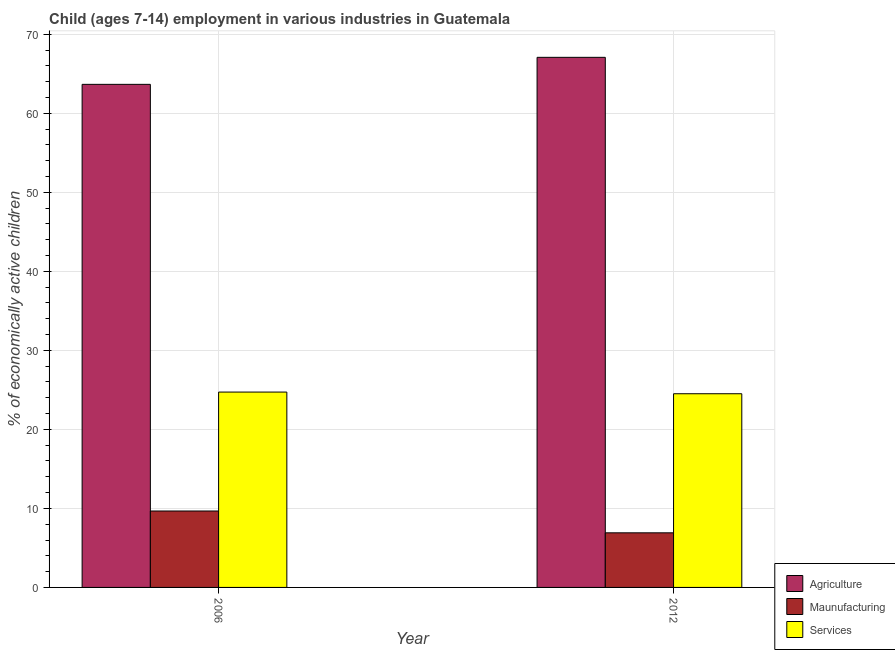How many bars are there on the 2nd tick from the right?
Your answer should be compact. 3. In how many cases, is the number of bars for a given year not equal to the number of legend labels?
Make the answer very short. 0. What is the percentage of economically active children in services in 2006?
Keep it short and to the point. 24.72. Across all years, what is the maximum percentage of economically active children in agriculture?
Offer a very short reply. 67.08. Across all years, what is the minimum percentage of economically active children in services?
Ensure brevity in your answer.  24.51. In which year was the percentage of economically active children in manufacturing maximum?
Ensure brevity in your answer.  2006. What is the total percentage of economically active children in agriculture in the graph?
Keep it short and to the point. 130.74. What is the difference between the percentage of economically active children in manufacturing in 2006 and that in 2012?
Your response must be concise. 2.76. What is the difference between the percentage of economically active children in manufacturing in 2006 and the percentage of economically active children in agriculture in 2012?
Provide a short and direct response. 2.76. What is the average percentage of economically active children in manufacturing per year?
Provide a short and direct response. 8.29. In how many years, is the percentage of economically active children in agriculture greater than 4 %?
Your answer should be compact. 2. What is the ratio of the percentage of economically active children in agriculture in 2006 to that in 2012?
Offer a very short reply. 0.95. In how many years, is the percentage of economically active children in agriculture greater than the average percentage of economically active children in agriculture taken over all years?
Your answer should be compact. 1. What does the 1st bar from the left in 2006 represents?
Provide a succinct answer. Agriculture. What does the 2nd bar from the right in 2012 represents?
Provide a succinct answer. Maunufacturing. Is it the case that in every year, the sum of the percentage of economically active children in agriculture and percentage of economically active children in manufacturing is greater than the percentage of economically active children in services?
Give a very brief answer. Yes. How many bars are there?
Your response must be concise. 6. How many years are there in the graph?
Your answer should be compact. 2. Are the values on the major ticks of Y-axis written in scientific E-notation?
Keep it short and to the point. No. Does the graph contain any zero values?
Your answer should be very brief. No. How many legend labels are there?
Offer a very short reply. 3. What is the title of the graph?
Offer a very short reply. Child (ages 7-14) employment in various industries in Guatemala. What is the label or title of the Y-axis?
Your answer should be compact. % of economically active children. What is the % of economically active children in Agriculture in 2006?
Your answer should be compact. 63.66. What is the % of economically active children in Maunufacturing in 2006?
Keep it short and to the point. 9.67. What is the % of economically active children of Services in 2006?
Give a very brief answer. 24.72. What is the % of economically active children in Agriculture in 2012?
Offer a very short reply. 67.08. What is the % of economically active children of Maunufacturing in 2012?
Your answer should be compact. 6.91. What is the % of economically active children in Services in 2012?
Your answer should be very brief. 24.51. Across all years, what is the maximum % of economically active children of Agriculture?
Make the answer very short. 67.08. Across all years, what is the maximum % of economically active children of Maunufacturing?
Provide a short and direct response. 9.67. Across all years, what is the maximum % of economically active children of Services?
Provide a succinct answer. 24.72. Across all years, what is the minimum % of economically active children in Agriculture?
Your answer should be compact. 63.66. Across all years, what is the minimum % of economically active children of Maunufacturing?
Your answer should be compact. 6.91. Across all years, what is the minimum % of economically active children in Services?
Offer a terse response. 24.51. What is the total % of economically active children in Agriculture in the graph?
Make the answer very short. 130.74. What is the total % of economically active children in Maunufacturing in the graph?
Your response must be concise. 16.58. What is the total % of economically active children in Services in the graph?
Offer a terse response. 49.23. What is the difference between the % of economically active children of Agriculture in 2006 and that in 2012?
Give a very brief answer. -3.42. What is the difference between the % of economically active children in Maunufacturing in 2006 and that in 2012?
Offer a terse response. 2.76. What is the difference between the % of economically active children in Services in 2006 and that in 2012?
Keep it short and to the point. 0.21. What is the difference between the % of economically active children in Agriculture in 2006 and the % of economically active children in Maunufacturing in 2012?
Offer a terse response. 56.75. What is the difference between the % of economically active children of Agriculture in 2006 and the % of economically active children of Services in 2012?
Give a very brief answer. 39.15. What is the difference between the % of economically active children of Maunufacturing in 2006 and the % of economically active children of Services in 2012?
Your response must be concise. -14.84. What is the average % of economically active children of Agriculture per year?
Offer a terse response. 65.37. What is the average % of economically active children of Maunufacturing per year?
Offer a terse response. 8.29. What is the average % of economically active children in Services per year?
Keep it short and to the point. 24.61. In the year 2006, what is the difference between the % of economically active children in Agriculture and % of economically active children in Maunufacturing?
Your response must be concise. 53.99. In the year 2006, what is the difference between the % of economically active children in Agriculture and % of economically active children in Services?
Keep it short and to the point. 38.94. In the year 2006, what is the difference between the % of economically active children of Maunufacturing and % of economically active children of Services?
Make the answer very short. -15.05. In the year 2012, what is the difference between the % of economically active children in Agriculture and % of economically active children in Maunufacturing?
Your response must be concise. 60.17. In the year 2012, what is the difference between the % of economically active children in Agriculture and % of economically active children in Services?
Offer a terse response. 42.57. In the year 2012, what is the difference between the % of economically active children of Maunufacturing and % of economically active children of Services?
Give a very brief answer. -17.6. What is the ratio of the % of economically active children of Agriculture in 2006 to that in 2012?
Provide a succinct answer. 0.95. What is the ratio of the % of economically active children of Maunufacturing in 2006 to that in 2012?
Ensure brevity in your answer.  1.4. What is the ratio of the % of economically active children in Services in 2006 to that in 2012?
Provide a short and direct response. 1.01. What is the difference between the highest and the second highest % of economically active children in Agriculture?
Provide a short and direct response. 3.42. What is the difference between the highest and the second highest % of economically active children of Maunufacturing?
Give a very brief answer. 2.76. What is the difference between the highest and the second highest % of economically active children of Services?
Provide a succinct answer. 0.21. What is the difference between the highest and the lowest % of economically active children of Agriculture?
Offer a terse response. 3.42. What is the difference between the highest and the lowest % of economically active children in Maunufacturing?
Keep it short and to the point. 2.76. What is the difference between the highest and the lowest % of economically active children of Services?
Ensure brevity in your answer.  0.21. 